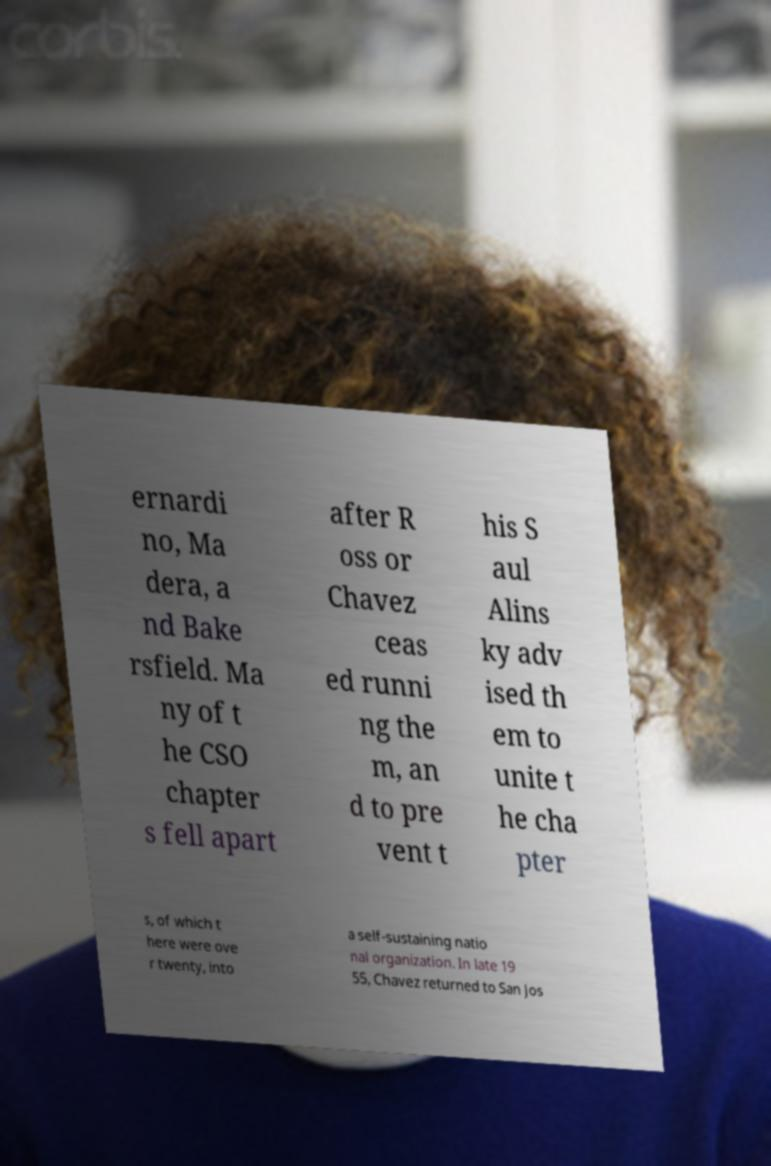Please identify and transcribe the text found in this image. ernardi no, Ma dera, a nd Bake rsfield. Ma ny of t he CSO chapter s fell apart after R oss or Chavez ceas ed runni ng the m, an d to pre vent t his S aul Alins ky adv ised th em to unite t he cha pter s, of which t here were ove r twenty, into a self-sustaining natio nal organization. In late 19 55, Chavez returned to San Jos 